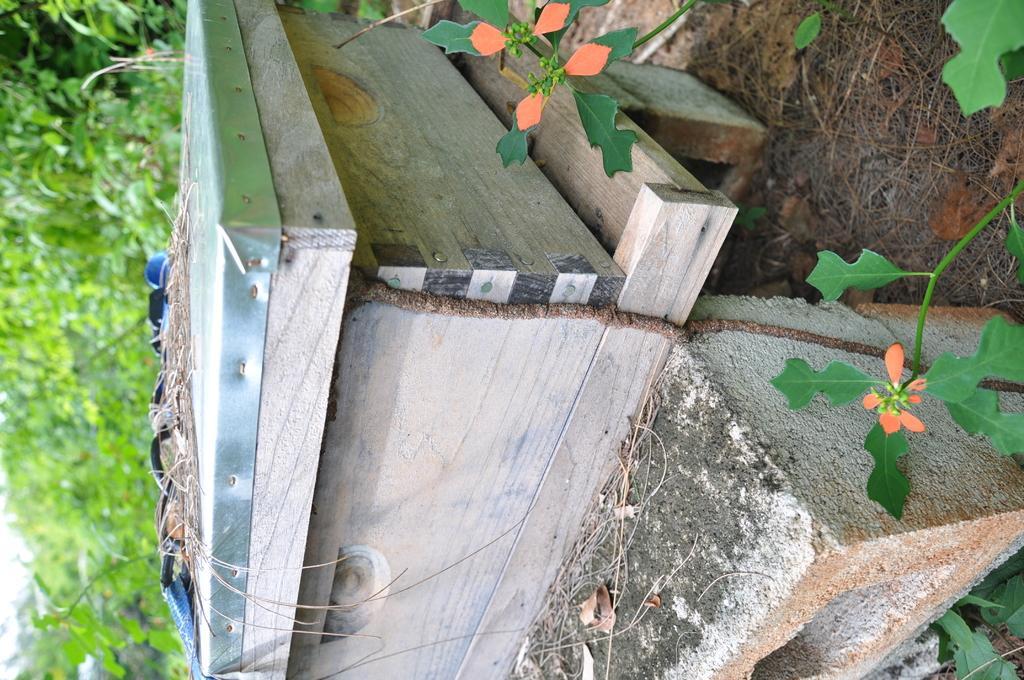How would you summarize this image in a sentence or two? In the center of the image we can see one wooden object on the two solid structures. On the wooden object, we can see one blue color object. In the background we can see plants, dry leaves, flowers and a few other objects. 